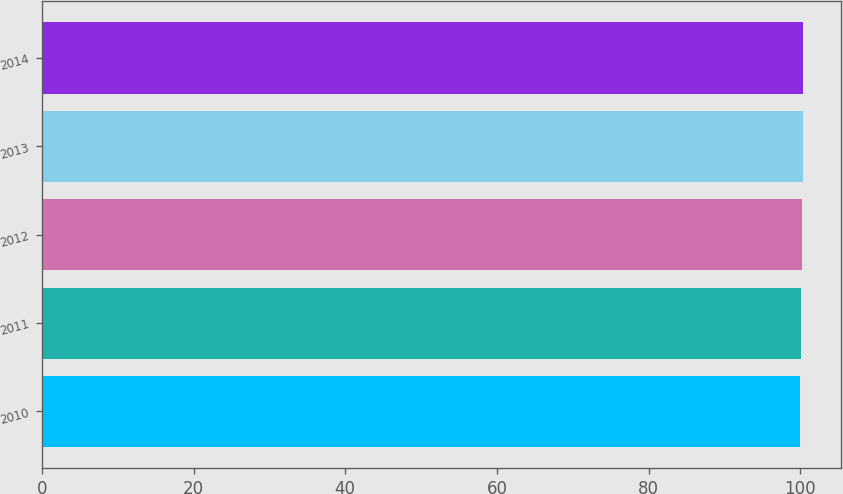Convert chart. <chart><loc_0><loc_0><loc_500><loc_500><bar_chart><fcel>2010<fcel>2011<fcel>2012<fcel>2013<fcel>2014<nl><fcel>100<fcel>100.1<fcel>100.2<fcel>100.3<fcel>100.4<nl></chart> 